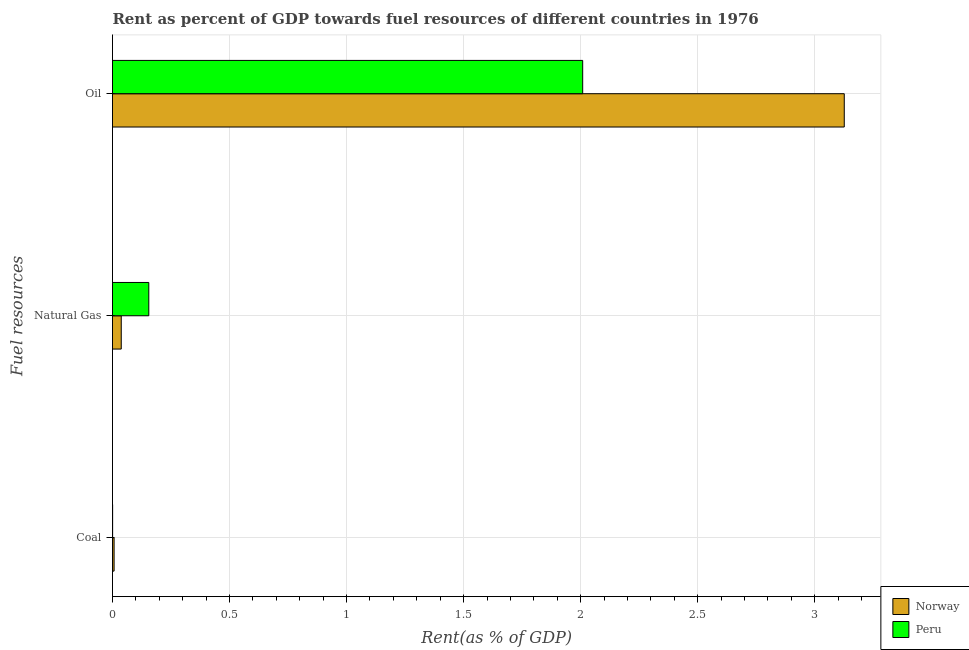How many bars are there on the 3rd tick from the top?
Provide a short and direct response. 2. How many bars are there on the 2nd tick from the bottom?
Offer a terse response. 2. What is the label of the 2nd group of bars from the top?
Ensure brevity in your answer.  Natural Gas. What is the rent towards coal in Norway?
Your answer should be very brief. 0.01. Across all countries, what is the maximum rent towards natural gas?
Provide a short and direct response. 0.16. Across all countries, what is the minimum rent towards natural gas?
Make the answer very short. 0.04. In which country was the rent towards oil minimum?
Offer a terse response. Peru. What is the total rent towards coal in the graph?
Give a very brief answer. 0.01. What is the difference between the rent towards natural gas in Peru and that in Norway?
Your answer should be compact. 0.12. What is the difference between the rent towards oil in Peru and the rent towards coal in Norway?
Your response must be concise. 2. What is the average rent towards oil per country?
Your answer should be compact. 2.57. What is the difference between the rent towards coal and rent towards oil in Peru?
Offer a terse response. -2.01. What is the ratio of the rent towards oil in Peru to that in Norway?
Give a very brief answer. 0.64. What is the difference between the highest and the second highest rent towards coal?
Ensure brevity in your answer.  0.01. What is the difference between the highest and the lowest rent towards natural gas?
Your response must be concise. 0.12. Is the sum of the rent towards natural gas in Peru and Norway greater than the maximum rent towards oil across all countries?
Provide a succinct answer. No. What does the 1st bar from the bottom in Oil represents?
Give a very brief answer. Norway. Is it the case that in every country, the sum of the rent towards coal and rent towards natural gas is greater than the rent towards oil?
Your answer should be very brief. No. How many countries are there in the graph?
Make the answer very short. 2. How many legend labels are there?
Make the answer very short. 2. How are the legend labels stacked?
Keep it short and to the point. Vertical. What is the title of the graph?
Make the answer very short. Rent as percent of GDP towards fuel resources of different countries in 1976. What is the label or title of the X-axis?
Your response must be concise. Rent(as % of GDP). What is the label or title of the Y-axis?
Provide a succinct answer. Fuel resources. What is the Rent(as % of GDP) of Norway in Coal?
Provide a succinct answer. 0.01. What is the Rent(as % of GDP) in Peru in Coal?
Offer a terse response. 0. What is the Rent(as % of GDP) of Norway in Natural Gas?
Make the answer very short. 0.04. What is the Rent(as % of GDP) in Peru in Natural Gas?
Your answer should be compact. 0.16. What is the Rent(as % of GDP) in Norway in Oil?
Your answer should be compact. 3.13. What is the Rent(as % of GDP) in Peru in Oil?
Offer a terse response. 2.01. Across all Fuel resources, what is the maximum Rent(as % of GDP) in Norway?
Offer a terse response. 3.13. Across all Fuel resources, what is the maximum Rent(as % of GDP) of Peru?
Your response must be concise. 2.01. Across all Fuel resources, what is the minimum Rent(as % of GDP) in Norway?
Your response must be concise. 0.01. Across all Fuel resources, what is the minimum Rent(as % of GDP) of Peru?
Offer a very short reply. 0. What is the total Rent(as % of GDP) in Norway in the graph?
Provide a succinct answer. 3.17. What is the total Rent(as % of GDP) of Peru in the graph?
Your answer should be very brief. 2.16. What is the difference between the Rent(as % of GDP) of Norway in Coal and that in Natural Gas?
Your answer should be compact. -0.03. What is the difference between the Rent(as % of GDP) of Peru in Coal and that in Natural Gas?
Make the answer very short. -0.15. What is the difference between the Rent(as % of GDP) of Norway in Coal and that in Oil?
Offer a terse response. -3.12. What is the difference between the Rent(as % of GDP) of Peru in Coal and that in Oil?
Offer a terse response. -2.01. What is the difference between the Rent(as % of GDP) of Norway in Natural Gas and that in Oil?
Keep it short and to the point. -3.09. What is the difference between the Rent(as % of GDP) in Peru in Natural Gas and that in Oil?
Ensure brevity in your answer.  -1.85. What is the difference between the Rent(as % of GDP) of Norway in Coal and the Rent(as % of GDP) of Peru in Natural Gas?
Offer a terse response. -0.15. What is the difference between the Rent(as % of GDP) of Norway in Coal and the Rent(as % of GDP) of Peru in Oil?
Give a very brief answer. -2. What is the difference between the Rent(as % of GDP) of Norway in Natural Gas and the Rent(as % of GDP) of Peru in Oil?
Offer a very short reply. -1.97. What is the average Rent(as % of GDP) of Norway per Fuel resources?
Ensure brevity in your answer.  1.06. What is the average Rent(as % of GDP) of Peru per Fuel resources?
Provide a short and direct response. 0.72. What is the difference between the Rent(as % of GDP) of Norway and Rent(as % of GDP) of Peru in Coal?
Give a very brief answer. 0.01. What is the difference between the Rent(as % of GDP) in Norway and Rent(as % of GDP) in Peru in Natural Gas?
Give a very brief answer. -0.12. What is the difference between the Rent(as % of GDP) in Norway and Rent(as % of GDP) in Peru in Oil?
Offer a terse response. 1.12. What is the ratio of the Rent(as % of GDP) in Norway in Coal to that in Natural Gas?
Your answer should be compact. 0.18. What is the ratio of the Rent(as % of GDP) of Peru in Coal to that in Natural Gas?
Your response must be concise. 0. What is the ratio of the Rent(as % of GDP) of Norway in Coal to that in Oil?
Provide a succinct answer. 0. What is the ratio of the Rent(as % of GDP) of Norway in Natural Gas to that in Oil?
Offer a terse response. 0.01. What is the ratio of the Rent(as % of GDP) of Peru in Natural Gas to that in Oil?
Give a very brief answer. 0.08. What is the difference between the highest and the second highest Rent(as % of GDP) in Norway?
Give a very brief answer. 3.09. What is the difference between the highest and the second highest Rent(as % of GDP) of Peru?
Give a very brief answer. 1.85. What is the difference between the highest and the lowest Rent(as % of GDP) of Norway?
Keep it short and to the point. 3.12. What is the difference between the highest and the lowest Rent(as % of GDP) in Peru?
Your response must be concise. 2.01. 